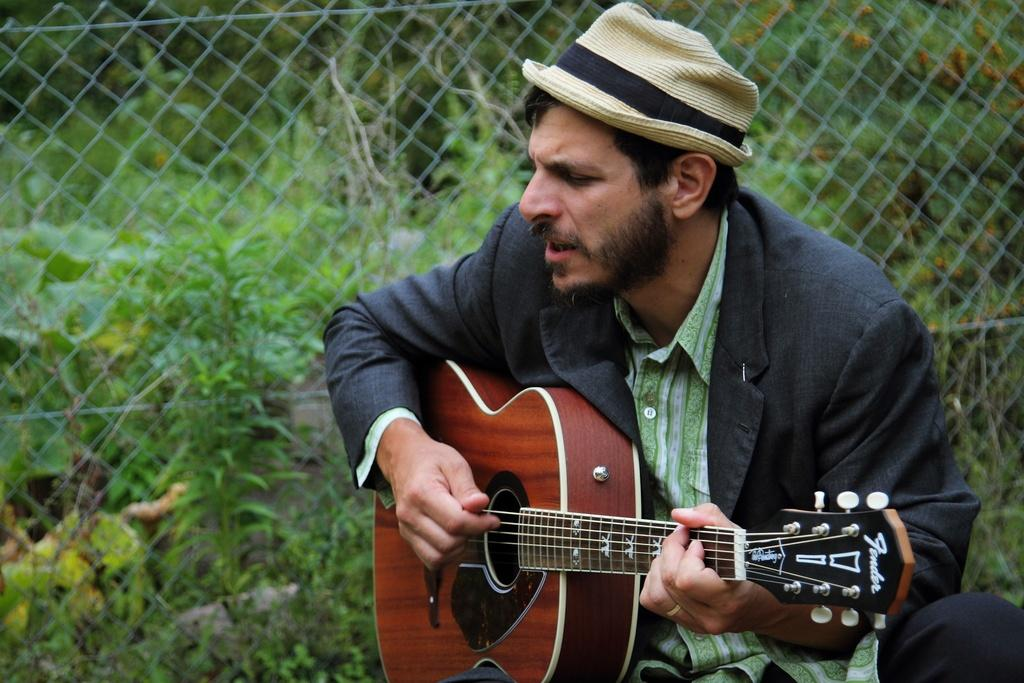What is the man in the image holding? The man is holding a guitar. What accessory is the man wearing in the image? The man is wearing a hat. What can be seen in the background of the image? There is grass and a fence in the background of the image. What type of birds can be seen flying over the man's head in the image? There are no birds visible in the image. 